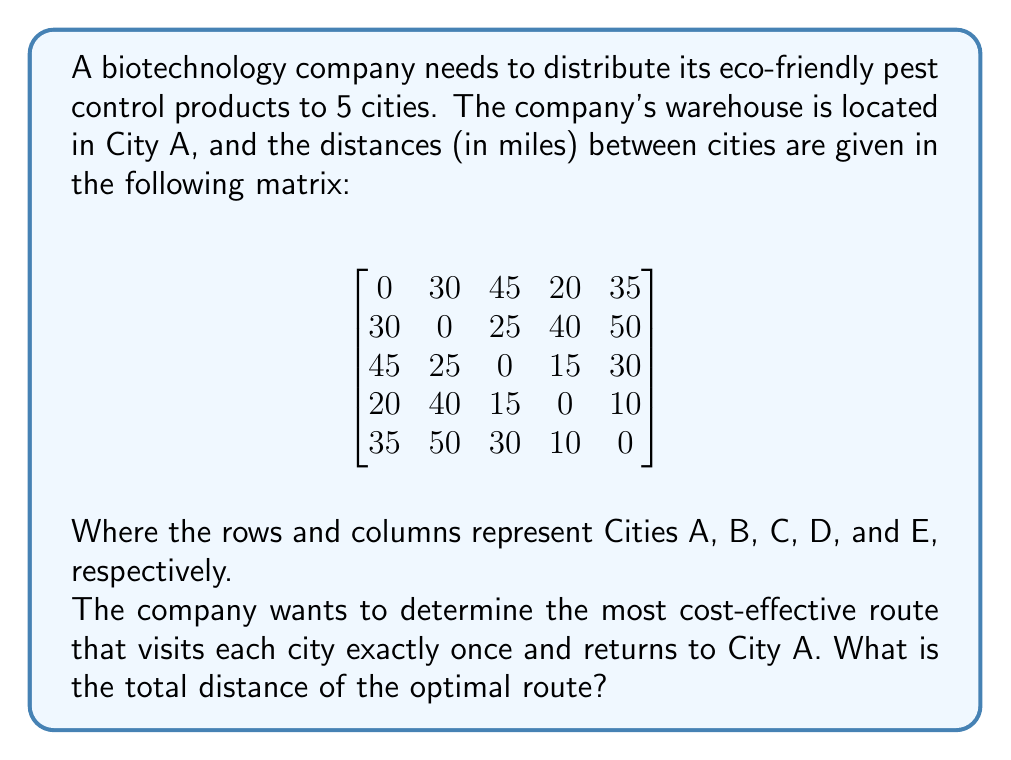What is the answer to this math problem? This problem is an instance of the Traveling Salesman Problem (TSP), which aims to find the shortest possible route that visits each city once and returns to the starting point.

To solve this problem, we can use the following steps:

1. Identify all possible routes:
   There are (5-1)! = 4! = 24 possible routes, as we start and end at City A.

2. Calculate the total distance for each route:
   For example, let's calculate the distance for route A-B-C-D-E-A:
   $$ 30 + 25 + 15 + 10 + 35 = 115 \text{ miles} $$

3. Compare all routes to find the shortest:
   After calculating all 24 routes, we find that the shortest route is:

   A → D → E → C → B → A

4. Calculate the total distance of the optimal route:
   $$ 20 + 10 + 30 + 25 + 30 = 115 \text{ miles} $$

This route minimizes the total distance traveled while visiting each city once and returning to the starting point (City A).
Answer: The total distance of the optimal route is 115 miles. 